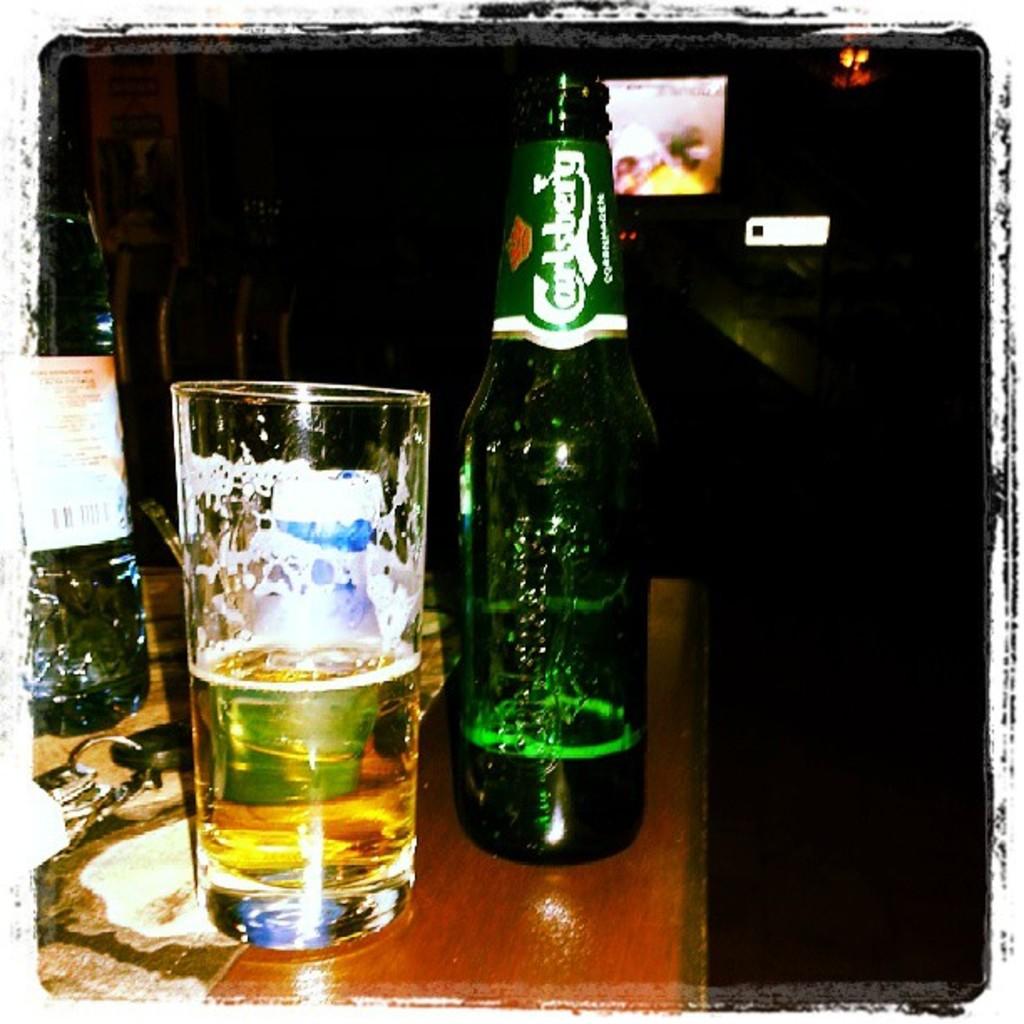What is this a bottle of?
Provide a succinct answer. Carlsberg. 